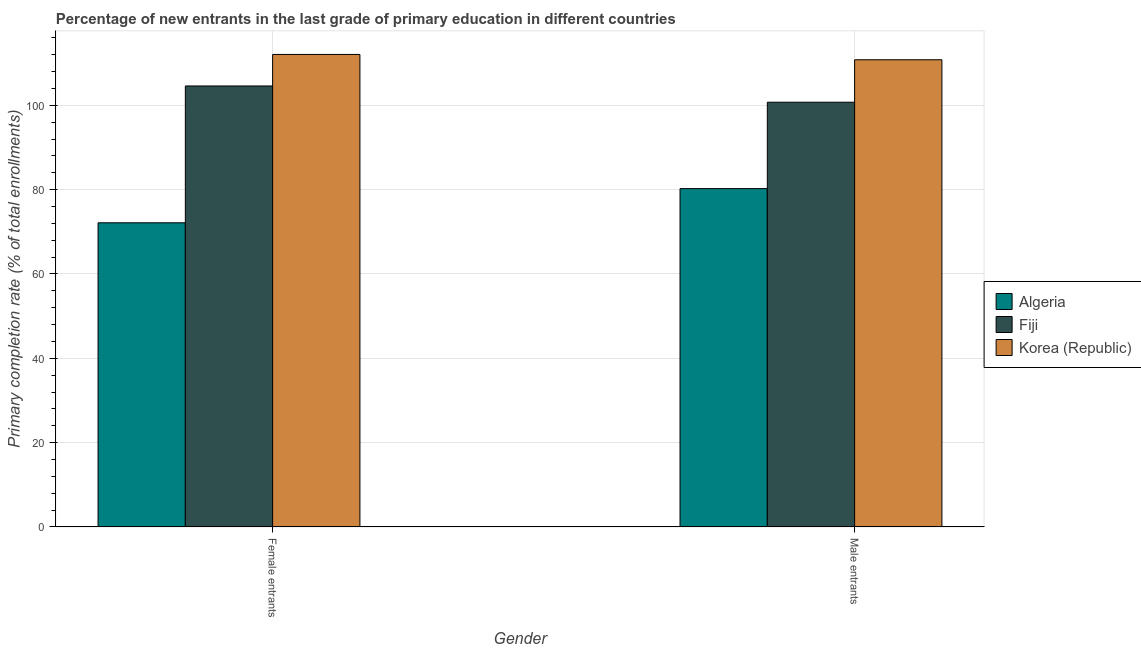How many different coloured bars are there?
Give a very brief answer. 3. Are the number of bars per tick equal to the number of legend labels?
Make the answer very short. Yes. How many bars are there on the 1st tick from the left?
Keep it short and to the point. 3. How many bars are there on the 2nd tick from the right?
Make the answer very short. 3. What is the label of the 2nd group of bars from the left?
Provide a short and direct response. Male entrants. What is the primary completion rate of male entrants in Fiji?
Ensure brevity in your answer.  100.73. Across all countries, what is the maximum primary completion rate of male entrants?
Provide a short and direct response. 110.8. Across all countries, what is the minimum primary completion rate of male entrants?
Ensure brevity in your answer.  80.24. In which country was the primary completion rate of female entrants maximum?
Give a very brief answer. Korea (Republic). In which country was the primary completion rate of male entrants minimum?
Keep it short and to the point. Algeria. What is the total primary completion rate of female entrants in the graph?
Provide a short and direct response. 288.78. What is the difference between the primary completion rate of female entrants in Fiji and that in Algeria?
Your response must be concise. 32.45. What is the difference between the primary completion rate of male entrants in Korea (Republic) and the primary completion rate of female entrants in Fiji?
Your response must be concise. 6.21. What is the average primary completion rate of female entrants per country?
Make the answer very short. 96.26. What is the difference between the primary completion rate of male entrants and primary completion rate of female entrants in Algeria?
Ensure brevity in your answer.  8.11. What is the ratio of the primary completion rate of female entrants in Fiji to that in Korea (Republic)?
Your response must be concise. 0.93. Is the primary completion rate of female entrants in Fiji less than that in Algeria?
Provide a succinct answer. No. What does the 1st bar from the left in Female entrants represents?
Ensure brevity in your answer.  Algeria. What does the 2nd bar from the right in Male entrants represents?
Keep it short and to the point. Fiji. Does the graph contain grids?
Your response must be concise. Yes. Where does the legend appear in the graph?
Offer a terse response. Center right. How many legend labels are there?
Provide a succinct answer. 3. How are the legend labels stacked?
Your answer should be very brief. Vertical. What is the title of the graph?
Keep it short and to the point. Percentage of new entrants in the last grade of primary education in different countries. What is the label or title of the X-axis?
Ensure brevity in your answer.  Gender. What is the label or title of the Y-axis?
Your answer should be very brief. Primary completion rate (% of total enrollments). What is the Primary completion rate (% of total enrollments) in Algeria in Female entrants?
Offer a terse response. 72.14. What is the Primary completion rate (% of total enrollments) of Fiji in Female entrants?
Keep it short and to the point. 104.58. What is the Primary completion rate (% of total enrollments) of Korea (Republic) in Female entrants?
Your answer should be very brief. 112.06. What is the Primary completion rate (% of total enrollments) of Algeria in Male entrants?
Your response must be concise. 80.24. What is the Primary completion rate (% of total enrollments) in Fiji in Male entrants?
Make the answer very short. 100.73. What is the Primary completion rate (% of total enrollments) in Korea (Republic) in Male entrants?
Provide a short and direct response. 110.8. Across all Gender, what is the maximum Primary completion rate (% of total enrollments) of Algeria?
Ensure brevity in your answer.  80.24. Across all Gender, what is the maximum Primary completion rate (% of total enrollments) in Fiji?
Make the answer very short. 104.58. Across all Gender, what is the maximum Primary completion rate (% of total enrollments) of Korea (Republic)?
Offer a terse response. 112.06. Across all Gender, what is the minimum Primary completion rate (% of total enrollments) of Algeria?
Your answer should be very brief. 72.14. Across all Gender, what is the minimum Primary completion rate (% of total enrollments) of Fiji?
Ensure brevity in your answer.  100.73. Across all Gender, what is the minimum Primary completion rate (% of total enrollments) in Korea (Republic)?
Make the answer very short. 110.8. What is the total Primary completion rate (% of total enrollments) of Algeria in the graph?
Give a very brief answer. 152.38. What is the total Primary completion rate (% of total enrollments) of Fiji in the graph?
Offer a terse response. 205.32. What is the total Primary completion rate (% of total enrollments) in Korea (Republic) in the graph?
Give a very brief answer. 222.85. What is the difference between the Primary completion rate (% of total enrollments) of Algeria in Female entrants and that in Male entrants?
Keep it short and to the point. -8.11. What is the difference between the Primary completion rate (% of total enrollments) in Fiji in Female entrants and that in Male entrants?
Offer a very short reply. 3.85. What is the difference between the Primary completion rate (% of total enrollments) of Korea (Republic) in Female entrants and that in Male entrants?
Offer a very short reply. 1.26. What is the difference between the Primary completion rate (% of total enrollments) of Algeria in Female entrants and the Primary completion rate (% of total enrollments) of Fiji in Male entrants?
Your response must be concise. -28.59. What is the difference between the Primary completion rate (% of total enrollments) in Algeria in Female entrants and the Primary completion rate (% of total enrollments) in Korea (Republic) in Male entrants?
Give a very brief answer. -38.66. What is the difference between the Primary completion rate (% of total enrollments) of Fiji in Female entrants and the Primary completion rate (% of total enrollments) of Korea (Republic) in Male entrants?
Offer a terse response. -6.21. What is the average Primary completion rate (% of total enrollments) of Algeria per Gender?
Keep it short and to the point. 76.19. What is the average Primary completion rate (% of total enrollments) in Fiji per Gender?
Provide a short and direct response. 102.66. What is the average Primary completion rate (% of total enrollments) in Korea (Republic) per Gender?
Provide a short and direct response. 111.43. What is the difference between the Primary completion rate (% of total enrollments) of Algeria and Primary completion rate (% of total enrollments) of Fiji in Female entrants?
Offer a terse response. -32.45. What is the difference between the Primary completion rate (% of total enrollments) in Algeria and Primary completion rate (% of total enrollments) in Korea (Republic) in Female entrants?
Offer a terse response. -39.92. What is the difference between the Primary completion rate (% of total enrollments) of Fiji and Primary completion rate (% of total enrollments) of Korea (Republic) in Female entrants?
Give a very brief answer. -7.47. What is the difference between the Primary completion rate (% of total enrollments) of Algeria and Primary completion rate (% of total enrollments) of Fiji in Male entrants?
Ensure brevity in your answer.  -20.49. What is the difference between the Primary completion rate (% of total enrollments) in Algeria and Primary completion rate (% of total enrollments) in Korea (Republic) in Male entrants?
Ensure brevity in your answer.  -30.55. What is the difference between the Primary completion rate (% of total enrollments) in Fiji and Primary completion rate (% of total enrollments) in Korea (Republic) in Male entrants?
Provide a short and direct response. -10.07. What is the ratio of the Primary completion rate (% of total enrollments) in Algeria in Female entrants to that in Male entrants?
Your answer should be very brief. 0.9. What is the ratio of the Primary completion rate (% of total enrollments) in Fiji in Female entrants to that in Male entrants?
Your answer should be compact. 1.04. What is the ratio of the Primary completion rate (% of total enrollments) of Korea (Republic) in Female entrants to that in Male entrants?
Provide a short and direct response. 1.01. What is the difference between the highest and the second highest Primary completion rate (% of total enrollments) of Algeria?
Keep it short and to the point. 8.11. What is the difference between the highest and the second highest Primary completion rate (% of total enrollments) in Fiji?
Your answer should be compact. 3.85. What is the difference between the highest and the second highest Primary completion rate (% of total enrollments) in Korea (Republic)?
Your response must be concise. 1.26. What is the difference between the highest and the lowest Primary completion rate (% of total enrollments) of Algeria?
Provide a succinct answer. 8.11. What is the difference between the highest and the lowest Primary completion rate (% of total enrollments) of Fiji?
Your answer should be compact. 3.85. What is the difference between the highest and the lowest Primary completion rate (% of total enrollments) of Korea (Republic)?
Provide a succinct answer. 1.26. 